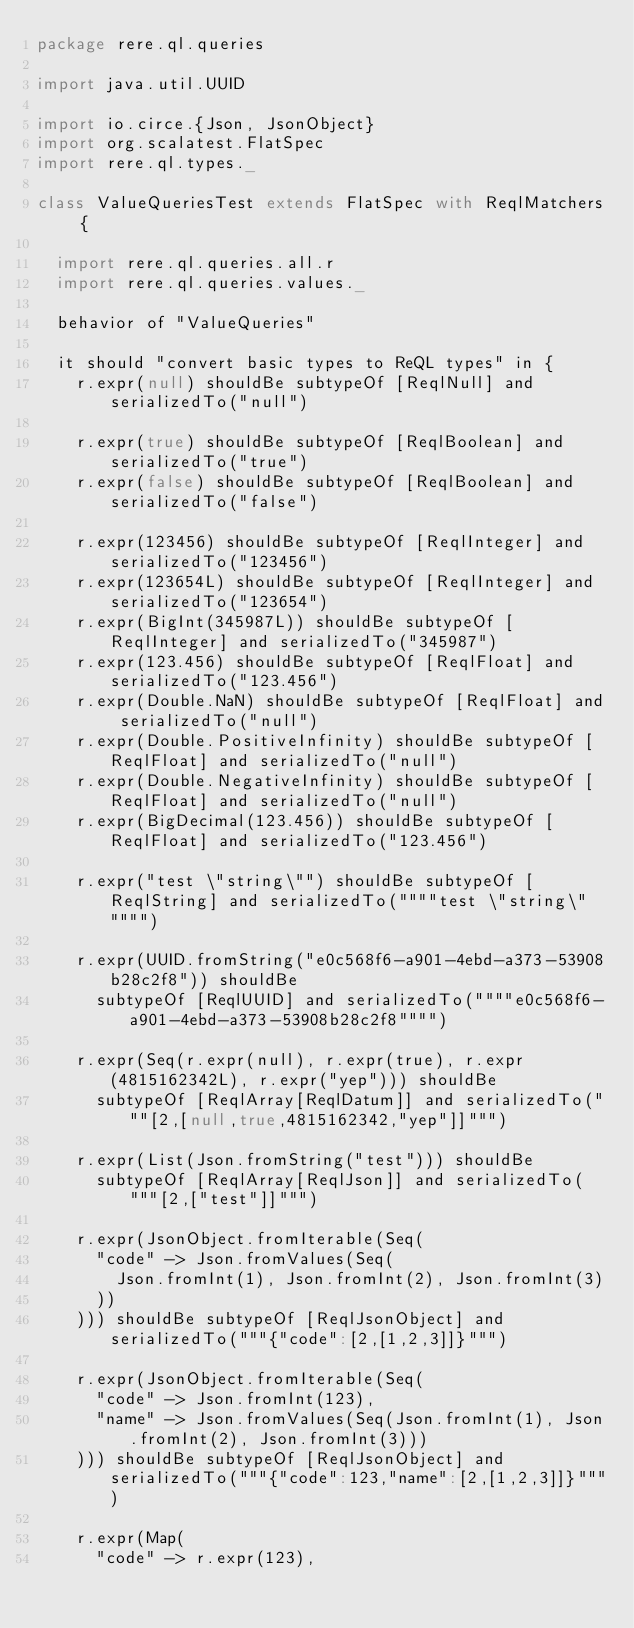<code> <loc_0><loc_0><loc_500><loc_500><_Scala_>package rere.ql.queries

import java.util.UUID

import io.circe.{Json, JsonObject}
import org.scalatest.FlatSpec
import rere.ql.types._

class ValueQueriesTest extends FlatSpec with ReqlMatchers {

  import rere.ql.queries.all.r
  import rere.ql.queries.values._

  behavior of "ValueQueries"

  it should "convert basic types to ReQL types" in {
    r.expr(null) shouldBe subtypeOf [ReqlNull] and serializedTo("null")

    r.expr(true) shouldBe subtypeOf [ReqlBoolean] and serializedTo("true")
    r.expr(false) shouldBe subtypeOf [ReqlBoolean] and serializedTo("false")

    r.expr(123456) shouldBe subtypeOf [ReqlInteger] and serializedTo("123456")
    r.expr(123654L) shouldBe subtypeOf [ReqlInteger] and serializedTo("123654")
    r.expr(BigInt(345987L)) shouldBe subtypeOf [ReqlInteger] and serializedTo("345987")
    r.expr(123.456) shouldBe subtypeOf [ReqlFloat] and serializedTo("123.456")
    r.expr(Double.NaN) shouldBe subtypeOf [ReqlFloat] and serializedTo("null")
    r.expr(Double.PositiveInfinity) shouldBe subtypeOf [ReqlFloat] and serializedTo("null")
    r.expr(Double.NegativeInfinity) shouldBe subtypeOf [ReqlFloat] and serializedTo("null")
    r.expr(BigDecimal(123.456)) shouldBe subtypeOf [ReqlFloat] and serializedTo("123.456")

    r.expr("test \"string\"") shouldBe subtypeOf [ReqlString] and serializedTo(""""test \"string\""""")

    r.expr(UUID.fromString("e0c568f6-a901-4ebd-a373-53908b28c2f8")) shouldBe
      subtypeOf [ReqlUUID] and serializedTo(""""e0c568f6-a901-4ebd-a373-53908b28c2f8"""")

    r.expr(Seq(r.expr(null), r.expr(true), r.expr(4815162342L), r.expr("yep"))) shouldBe
      subtypeOf [ReqlArray[ReqlDatum]] and serializedTo("""[2,[null,true,4815162342,"yep"]]""")

    r.expr(List(Json.fromString("test"))) shouldBe
      subtypeOf [ReqlArray[ReqlJson]] and serializedTo("""[2,["test"]]""")

    r.expr(JsonObject.fromIterable(Seq(
      "code" -> Json.fromValues(Seq(
        Json.fromInt(1), Json.fromInt(2), Json.fromInt(3)
      ))
    ))) shouldBe subtypeOf [ReqlJsonObject] and serializedTo("""{"code":[2,[1,2,3]]}""")

    r.expr(JsonObject.fromIterable(Seq(
      "code" -> Json.fromInt(123),
      "name" -> Json.fromValues(Seq(Json.fromInt(1), Json.fromInt(2), Json.fromInt(3)))
    ))) shouldBe subtypeOf [ReqlJsonObject] and serializedTo("""{"code":123,"name":[2,[1,2,3]]}""")

    r.expr(Map(
      "code" -> r.expr(123),</code> 